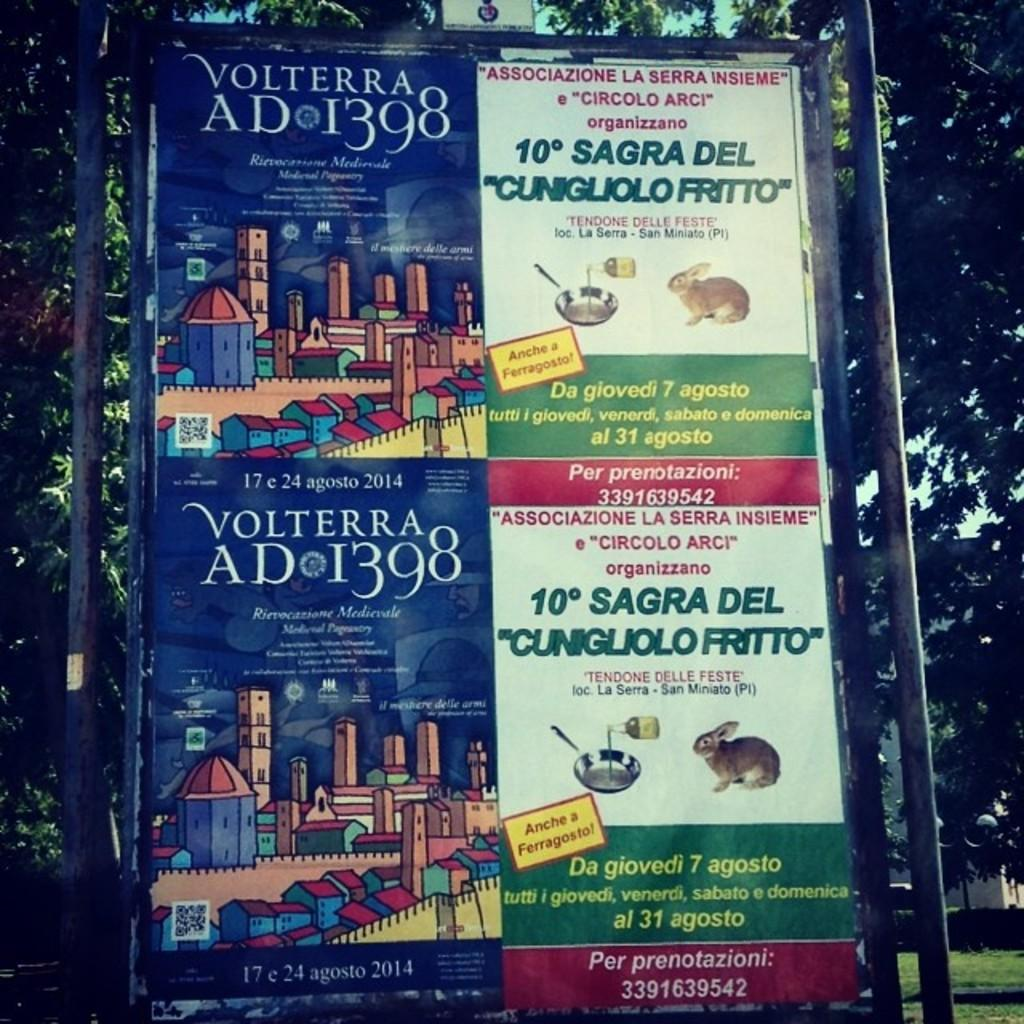<image>
Render a clear and concise summary of the photo. An Italian advertisement previews an event in Volterra and a festival of a fried rabbit. 